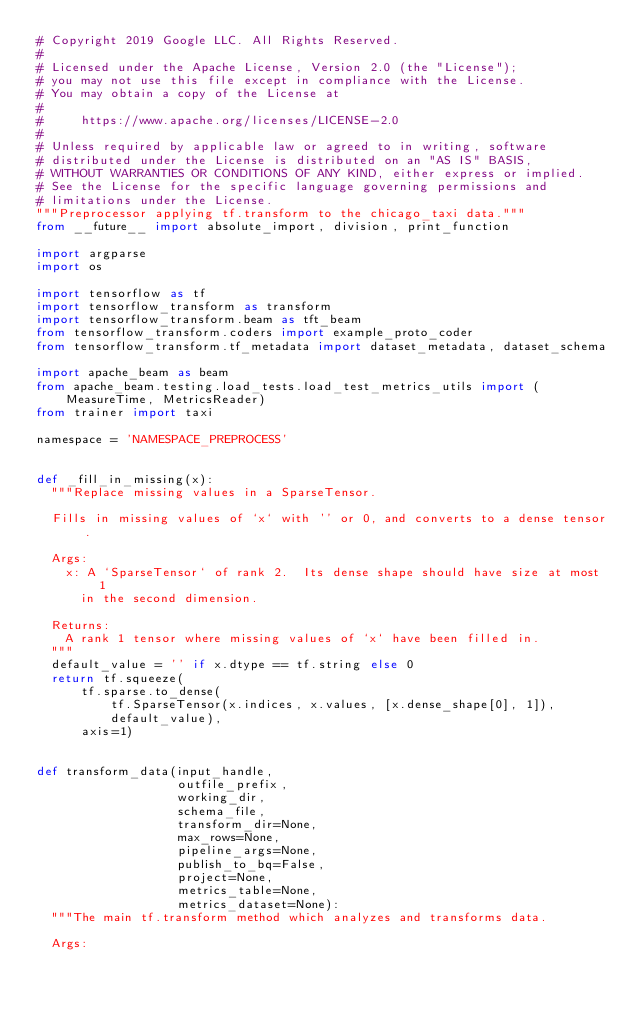<code> <loc_0><loc_0><loc_500><loc_500><_Python_># Copyright 2019 Google LLC. All Rights Reserved.
#
# Licensed under the Apache License, Version 2.0 (the "License");
# you may not use this file except in compliance with the License.
# You may obtain a copy of the License at
#
#     https://www.apache.org/licenses/LICENSE-2.0
#
# Unless required by applicable law or agreed to in writing, software
# distributed under the License is distributed on an "AS IS" BASIS,
# WITHOUT WARRANTIES OR CONDITIONS OF ANY KIND, either express or implied.
# See the License for the specific language governing permissions and
# limitations under the License.
"""Preprocessor applying tf.transform to the chicago_taxi data."""
from __future__ import absolute_import, division, print_function

import argparse
import os

import tensorflow as tf
import tensorflow_transform as transform
import tensorflow_transform.beam as tft_beam
from tensorflow_transform.coders import example_proto_coder
from tensorflow_transform.tf_metadata import dataset_metadata, dataset_schema

import apache_beam as beam
from apache_beam.testing.load_tests.load_test_metrics_utils import (
    MeasureTime, MetricsReader)
from trainer import taxi

namespace = 'NAMESPACE_PREPROCESS'


def _fill_in_missing(x):
  """Replace missing values in a SparseTensor.

  Fills in missing values of `x` with '' or 0, and converts to a dense tensor.

  Args:
    x: A `SparseTensor` of rank 2.  Its dense shape should have size at most 1
      in the second dimension.

  Returns:
    A rank 1 tensor where missing values of `x` have been filled in.
  """
  default_value = '' if x.dtype == tf.string else 0
  return tf.squeeze(
      tf.sparse.to_dense(
          tf.SparseTensor(x.indices, x.values, [x.dense_shape[0], 1]),
          default_value),
      axis=1)


def transform_data(input_handle,
                   outfile_prefix,
                   working_dir,
                   schema_file,
                   transform_dir=None,
                   max_rows=None,
                   pipeline_args=None,
                   publish_to_bq=False,
                   project=None,
                   metrics_table=None,
                   metrics_dataset=None):
  """The main tf.transform method which analyzes and transforms data.

  Args:</code> 